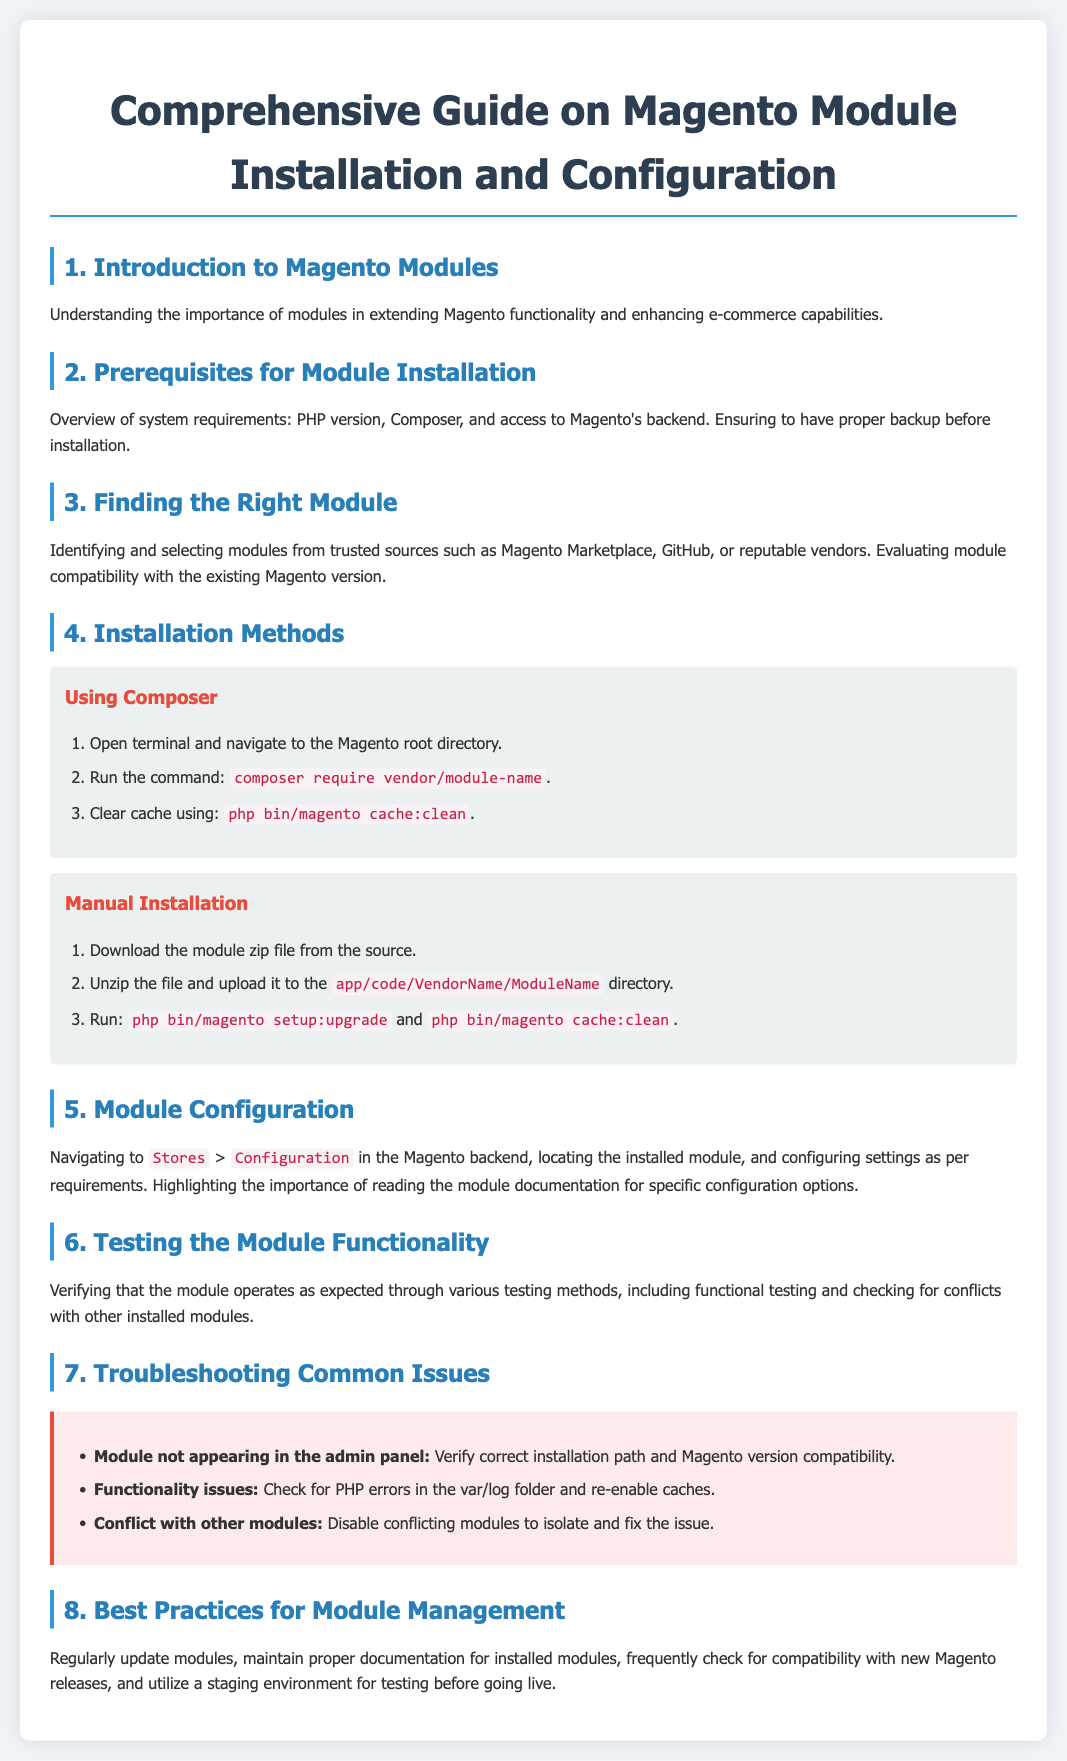What is the title of the document? The title of the document is stated in the <title> tag in the head section of the document.
Answer: Comprehensive Guide on Magento Module Installation and Configuration What are the prerequisites for module installation? The prerequisites are mentioned in section 2, focusing on system requirements and backup preparation.
Answer: PHP version, Composer, and access to Magento's backend How many installation methods are described? The document outlines different approaches to installation in section 4 and specifies the methods used.
Answer: Two What command is used to clear the cache after module installation? The command is listed as one of the steps in both installation methods.
Answer: php bin/magento cache:clean Where can you configure the installed module settings? The document provides specific navigation instructions for configuration settings.
Answer: Stores > Configuration What troubleshooting issue is addressed first? The first issue listed under troubleshooting points to a common problem with module visibility.
Answer: Module not appearing in the admin panel What is one best practice for module management? The document provides recommendations for maintaining installed modules.
Answer: Regularly update modules Which method involves using Composer? The document contains a specific section detailing the steps for this installation method.
Answer: Using Composer What section discusses testing the module functionality? The document refers to the section that covers ensuring the module works as intended.
Answer: 6. Testing the Module Functionality 